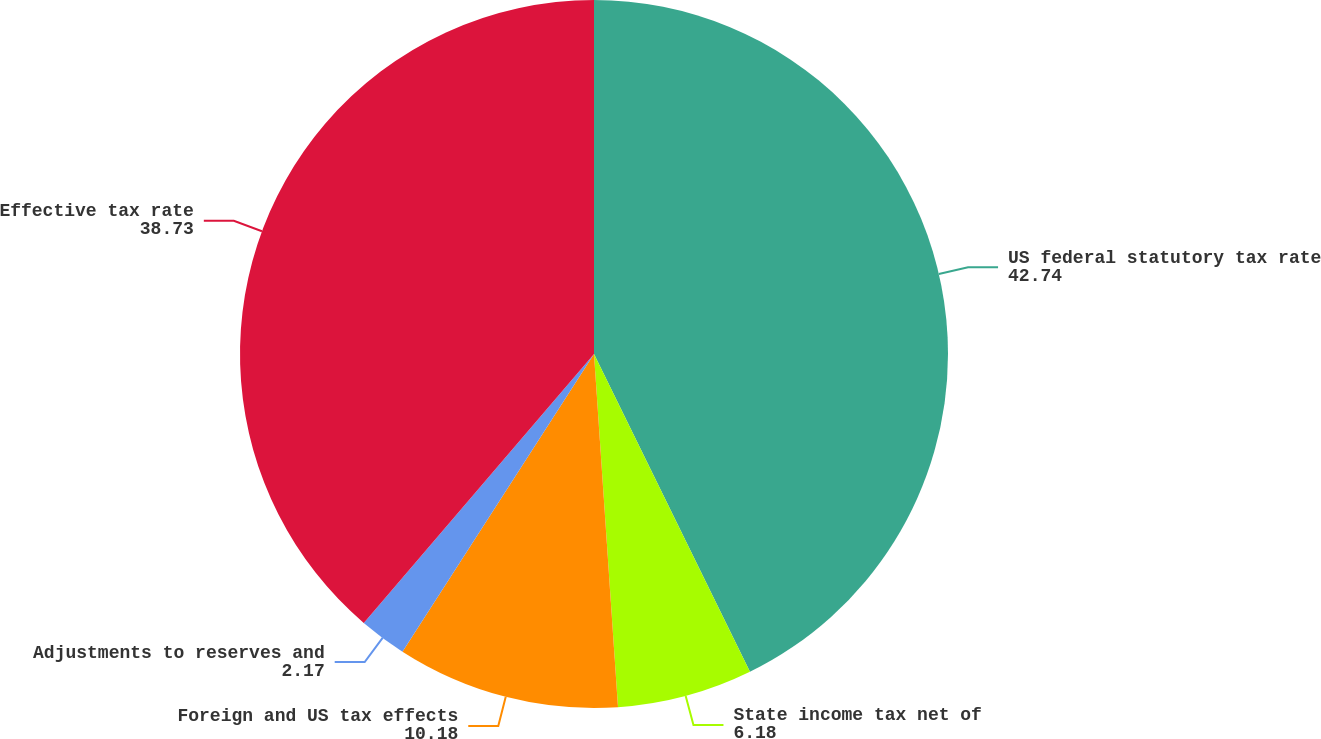Convert chart. <chart><loc_0><loc_0><loc_500><loc_500><pie_chart><fcel>US federal statutory tax rate<fcel>State income tax net of<fcel>Foreign and US tax effects<fcel>Adjustments to reserves and<fcel>Effective tax rate<nl><fcel>42.74%<fcel>6.18%<fcel>10.18%<fcel>2.17%<fcel>38.73%<nl></chart> 